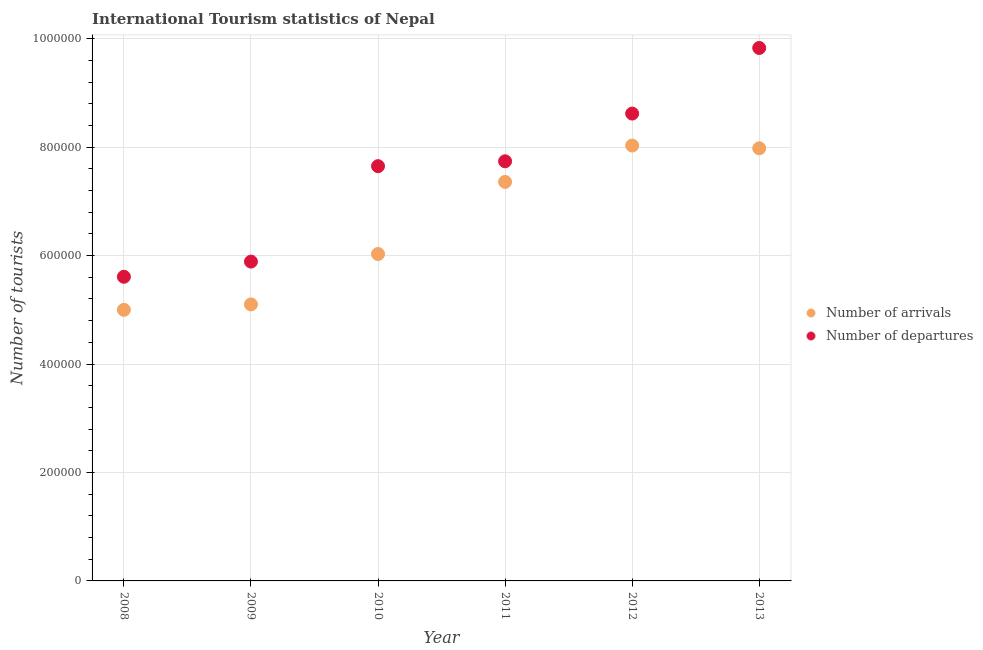How many different coloured dotlines are there?
Provide a succinct answer. 2. What is the number of tourist departures in 2012?
Give a very brief answer. 8.62e+05. Across all years, what is the maximum number of tourist departures?
Make the answer very short. 9.83e+05. Across all years, what is the minimum number of tourist departures?
Offer a very short reply. 5.61e+05. In which year was the number of tourist departures maximum?
Your answer should be very brief. 2013. What is the total number of tourist departures in the graph?
Offer a very short reply. 4.53e+06. What is the difference between the number of tourist arrivals in 2008 and that in 2010?
Give a very brief answer. -1.03e+05. What is the difference between the number of tourist departures in 2010 and the number of tourist arrivals in 2008?
Your answer should be very brief. 2.65e+05. What is the average number of tourist arrivals per year?
Offer a very short reply. 6.58e+05. In the year 2010, what is the difference between the number of tourist departures and number of tourist arrivals?
Provide a succinct answer. 1.62e+05. What is the ratio of the number of tourist arrivals in 2010 to that in 2011?
Offer a terse response. 0.82. Is the difference between the number of tourist departures in 2008 and 2013 greater than the difference between the number of tourist arrivals in 2008 and 2013?
Provide a short and direct response. No. What is the difference between the highest and the second highest number of tourist arrivals?
Provide a succinct answer. 5000. What is the difference between the highest and the lowest number of tourist departures?
Keep it short and to the point. 4.22e+05. In how many years, is the number of tourist departures greater than the average number of tourist departures taken over all years?
Your answer should be very brief. 4. Is the number of tourist arrivals strictly greater than the number of tourist departures over the years?
Ensure brevity in your answer.  No. Is the number of tourist departures strictly less than the number of tourist arrivals over the years?
Ensure brevity in your answer.  No. How many dotlines are there?
Your response must be concise. 2. How many years are there in the graph?
Give a very brief answer. 6. Are the values on the major ticks of Y-axis written in scientific E-notation?
Offer a terse response. No. Does the graph contain any zero values?
Offer a terse response. No. Does the graph contain grids?
Offer a terse response. Yes. Where does the legend appear in the graph?
Your answer should be compact. Center right. How are the legend labels stacked?
Your response must be concise. Vertical. What is the title of the graph?
Provide a short and direct response. International Tourism statistics of Nepal. What is the label or title of the Y-axis?
Offer a very short reply. Number of tourists. What is the Number of tourists in Number of arrivals in 2008?
Offer a terse response. 5.00e+05. What is the Number of tourists in Number of departures in 2008?
Offer a very short reply. 5.61e+05. What is the Number of tourists in Number of arrivals in 2009?
Provide a succinct answer. 5.10e+05. What is the Number of tourists of Number of departures in 2009?
Your answer should be compact. 5.89e+05. What is the Number of tourists in Number of arrivals in 2010?
Your answer should be very brief. 6.03e+05. What is the Number of tourists in Number of departures in 2010?
Provide a short and direct response. 7.65e+05. What is the Number of tourists of Number of arrivals in 2011?
Ensure brevity in your answer.  7.36e+05. What is the Number of tourists of Number of departures in 2011?
Provide a short and direct response. 7.74e+05. What is the Number of tourists in Number of arrivals in 2012?
Give a very brief answer. 8.03e+05. What is the Number of tourists of Number of departures in 2012?
Your response must be concise. 8.62e+05. What is the Number of tourists of Number of arrivals in 2013?
Offer a very short reply. 7.98e+05. What is the Number of tourists of Number of departures in 2013?
Provide a short and direct response. 9.83e+05. Across all years, what is the maximum Number of tourists of Number of arrivals?
Your answer should be very brief. 8.03e+05. Across all years, what is the maximum Number of tourists in Number of departures?
Provide a short and direct response. 9.83e+05. Across all years, what is the minimum Number of tourists in Number of departures?
Provide a succinct answer. 5.61e+05. What is the total Number of tourists of Number of arrivals in the graph?
Your answer should be compact. 3.95e+06. What is the total Number of tourists of Number of departures in the graph?
Keep it short and to the point. 4.53e+06. What is the difference between the Number of tourists of Number of arrivals in 2008 and that in 2009?
Provide a succinct answer. -10000. What is the difference between the Number of tourists in Number of departures in 2008 and that in 2009?
Give a very brief answer. -2.80e+04. What is the difference between the Number of tourists in Number of arrivals in 2008 and that in 2010?
Provide a succinct answer. -1.03e+05. What is the difference between the Number of tourists in Number of departures in 2008 and that in 2010?
Make the answer very short. -2.04e+05. What is the difference between the Number of tourists of Number of arrivals in 2008 and that in 2011?
Your response must be concise. -2.36e+05. What is the difference between the Number of tourists of Number of departures in 2008 and that in 2011?
Ensure brevity in your answer.  -2.13e+05. What is the difference between the Number of tourists in Number of arrivals in 2008 and that in 2012?
Offer a terse response. -3.03e+05. What is the difference between the Number of tourists in Number of departures in 2008 and that in 2012?
Your answer should be very brief. -3.01e+05. What is the difference between the Number of tourists in Number of arrivals in 2008 and that in 2013?
Keep it short and to the point. -2.98e+05. What is the difference between the Number of tourists in Number of departures in 2008 and that in 2013?
Your answer should be very brief. -4.22e+05. What is the difference between the Number of tourists of Number of arrivals in 2009 and that in 2010?
Make the answer very short. -9.30e+04. What is the difference between the Number of tourists in Number of departures in 2009 and that in 2010?
Keep it short and to the point. -1.76e+05. What is the difference between the Number of tourists in Number of arrivals in 2009 and that in 2011?
Keep it short and to the point. -2.26e+05. What is the difference between the Number of tourists of Number of departures in 2009 and that in 2011?
Give a very brief answer. -1.85e+05. What is the difference between the Number of tourists in Number of arrivals in 2009 and that in 2012?
Keep it short and to the point. -2.93e+05. What is the difference between the Number of tourists in Number of departures in 2009 and that in 2012?
Make the answer very short. -2.73e+05. What is the difference between the Number of tourists in Number of arrivals in 2009 and that in 2013?
Ensure brevity in your answer.  -2.88e+05. What is the difference between the Number of tourists of Number of departures in 2009 and that in 2013?
Provide a short and direct response. -3.94e+05. What is the difference between the Number of tourists in Number of arrivals in 2010 and that in 2011?
Offer a terse response. -1.33e+05. What is the difference between the Number of tourists in Number of departures in 2010 and that in 2011?
Your answer should be compact. -9000. What is the difference between the Number of tourists in Number of departures in 2010 and that in 2012?
Ensure brevity in your answer.  -9.70e+04. What is the difference between the Number of tourists of Number of arrivals in 2010 and that in 2013?
Provide a succinct answer. -1.95e+05. What is the difference between the Number of tourists of Number of departures in 2010 and that in 2013?
Offer a terse response. -2.18e+05. What is the difference between the Number of tourists in Number of arrivals in 2011 and that in 2012?
Give a very brief answer. -6.70e+04. What is the difference between the Number of tourists in Number of departures in 2011 and that in 2012?
Give a very brief answer. -8.80e+04. What is the difference between the Number of tourists of Number of arrivals in 2011 and that in 2013?
Make the answer very short. -6.20e+04. What is the difference between the Number of tourists of Number of departures in 2011 and that in 2013?
Provide a short and direct response. -2.09e+05. What is the difference between the Number of tourists of Number of arrivals in 2012 and that in 2013?
Ensure brevity in your answer.  5000. What is the difference between the Number of tourists in Number of departures in 2012 and that in 2013?
Keep it short and to the point. -1.21e+05. What is the difference between the Number of tourists of Number of arrivals in 2008 and the Number of tourists of Number of departures in 2009?
Ensure brevity in your answer.  -8.90e+04. What is the difference between the Number of tourists in Number of arrivals in 2008 and the Number of tourists in Number of departures in 2010?
Your response must be concise. -2.65e+05. What is the difference between the Number of tourists in Number of arrivals in 2008 and the Number of tourists in Number of departures in 2011?
Keep it short and to the point. -2.74e+05. What is the difference between the Number of tourists in Number of arrivals in 2008 and the Number of tourists in Number of departures in 2012?
Offer a very short reply. -3.62e+05. What is the difference between the Number of tourists in Number of arrivals in 2008 and the Number of tourists in Number of departures in 2013?
Make the answer very short. -4.83e+05. What is the difference between the Number of tourists of Number of arrivals in 2009 and the Number of tourists of Number of departures in 2010?
Make the answer very short. -2.55e+05. What is the difference between the Number of tourists in Number of arrivals in 2009 and the Number of tourists in Number of departures in 2011?
Offer a very short reply. -2.64e+05. What is the difference between the Number of tourists of Number of arrivals in 2009 and the Number of tourists of Number of departures in 2012?
Provide a succinct answer. -3.52e+05. What is the difference between the Number of tourists of Number of arrivals in 2009 and the Number of tourists of Number of departures in 2013?
Provide a short and direct response. -4.73e+05. What is the difference between the Number of tourists of Number of arrivals in 2010 and the Number of tourists of Number of departures in 2011?
Your answer should be compact. -1.71e+05. What is the difference between the Number of tourists of Number of arrivals in 2010 and the Number of tourists of Number of departures in 2012?
Offer a terse response. -2.59e+05. What is the difference between the Number of tourists of Number of arrivals in 2010 and the Number of tourists of Number of departures in 2013?
Offer a terse response. -3.80e+05. What is the difference between the Number of tourists of Number of arrivals in 2011 and the Number of tourists of Number of departures in 2012?
Make the answer very short. -1.26e+05. What is the difference between the Number of tourists of Number of arrivals in 2011 and the Number of tourists of Number of departures in 2013?
Your answer should be compact. -2.47e+05. What is the average Number of tourists of Number of arrivals per year?
Your answer should be very brief. 6.58e+05. What is the average Number of tourists in Number of departures per year?
Offer a terse response. 7.56e+05. In the year 2008, what is the difference between the Number of tourists of Number of arrivals and Number of tourists of Number of departures?
Your response must be concise. -6.10e+04. In the year 2009, what is the difference between the Number of tourists of Number of arrivals and Number of tourists of Number of departures?
Give a very brief answer. -7.90e+04. In the year 2010, what is the difference between the Number of tourists in Number of arrivals and Number of tourists in Number of departures?
Your response must be concise. -1.62e+05. In the year 2011, what is the difference between the Number of tourists of Number of arrivals and Number of tourists of Number of departures?
Provide a short and direct response. -3.80e+04. In the year 2012, what is the difference between the Number of tourists of Number of arrivals and Number of tourists of Number of departures?
Provide a succinct answer. -5.90e+04. In the year 2013, what is the difference between the Number of tourists of Number of arrivals and Number of tourists of Number of departures?
Offer a terse response. -1.85e+05. What is the ratio of the Number of tourists of Number of arrivals in 2008 to that in 2009?
Make the answer very short. 0.98. What is the ratio of the Number of tourists of Number of departures in 2008 to that in 2009?
Provide a succinct answer. 0.95. What is the ratio of the Number of tourists in Number of arrivals in 2008 to that in 2010?
Offer a very short reply. 0.83. What is the ratio of the Number of tourists in Number of departures in 2008 to that in 2010?
Your response must be concise. 0.73. What is the ratio of the Number of tourists in Number of arrivals in 2008 to that in 2011?
Keep it short and to the point. 0.68. What is the ratio of the Number of tourists in Number of departures in 2008 to that in 2011?
Your answer should be compact. 0.72. What is the ratio of the Number of tourists of Number of arrivals in 2008 to that in 2012?
Ensure brevity in your answer.  0.62. What is the ratio of the Number of tourists in Number of departures in 2008 to that in 2012?
Give a very brief answer. 0.65. What is the ratio of the Number of tourists in Number of arrivals in 2008 to that in 2013?
Keep it short and to the point. 0.63. What is the ratio of the Number of tourists in Number of departures in 2008 to that in 2013?
Offer a very short reply. 0.57. What is the ratio of the Number of tourists of Number of arrivals in 2009 to that in 2010?
Provide a succinct answer. 0.85. What is the ratio of the Number of tourists in Number of departures in 2009 to that in 2010?
Make the answer very short. 0.77. What is the ratio of the Number of tourists in Number of arrivals in 2009 to that in 2011?
Offer a terse response. 0.69. What is the ratio of the Number of tourists of Number of departures in 2009 to that in 2011?
Keep it short and to the point. 0.76. What is the ratio of the Number of tourists of Number of arrivals in 2009 to that in 2012?
Ensure brevity in your answer.  0.64. What is the ratio of the Number of tourists in Number of departures in 2009 to that in 2012?
Make the answer very short. 0.68. What is the ratio of the Number of tourists in Number of arrivals in 2009 to that in 2013?
Keep it short and to the point. 0.64. What is the ratio of the Number of tourists in Number of departures in 2009 to that in 2013?
Your answer should be compact. 0.6. What is the ratio of the Number of tourists in Number of arrivals in 2010 to that in 2011?
Keep it short and to the point. 0.82. What is the ratio of the Number of tourists in Number of departures in 2010 to that in 2011?
Give a very brief answer. 0.99. What is the ratio of the Number of tourists in Number of arrivals in 2010 to that in 2012?
Your answer should be compact. 0.75. What is the ratio of the Number of tourists of Number of departures in 2010 to that in 2012?
Your response must be concise. 0.89. What is the ratio of the Number of tourists in Number of arrivals in 2010 to that in 2013?
Offer a terse response. 0.76. What is the ratio of the Number of tourists of Number of departures in 2010 to that in 2013?
Provide a short and direct response. 0.78. What is the ratio of the Number of tourists of Number of arrivals in 2011 to that in 2012?
Your response must be concise. 0.92. What is the ratio of the Number of tourists of Number of departures in 2011 to that in 2012?
Your answer should be very brief. 0.9. What is the ratio of the Number of tourists of Number of arrivals in 2011 to that in 2013?
Provide a short and direct response. 0.92. What is the ratio of the Number of tourists in Number of departures in 2011 to that in 2013?
Make the answer very short. 0.79. What is the ratio of the Number of tourists of Number of departures in 2012 to that in 2013?
Ensure brevity in your answer.  0.88. What is the difference between the highest and the second highest Number of tourists in Number of departures?
Make the answer very short. 1.21e+05. What is the difference between the highest and the lowest Number of tourists of Number of arrivals?
Provide a short and direct response. 3.03e+05. What is the difference between the highest and the lowest Number of tourists of Number of departures?
Offer a terse response. 4.22e+05. 